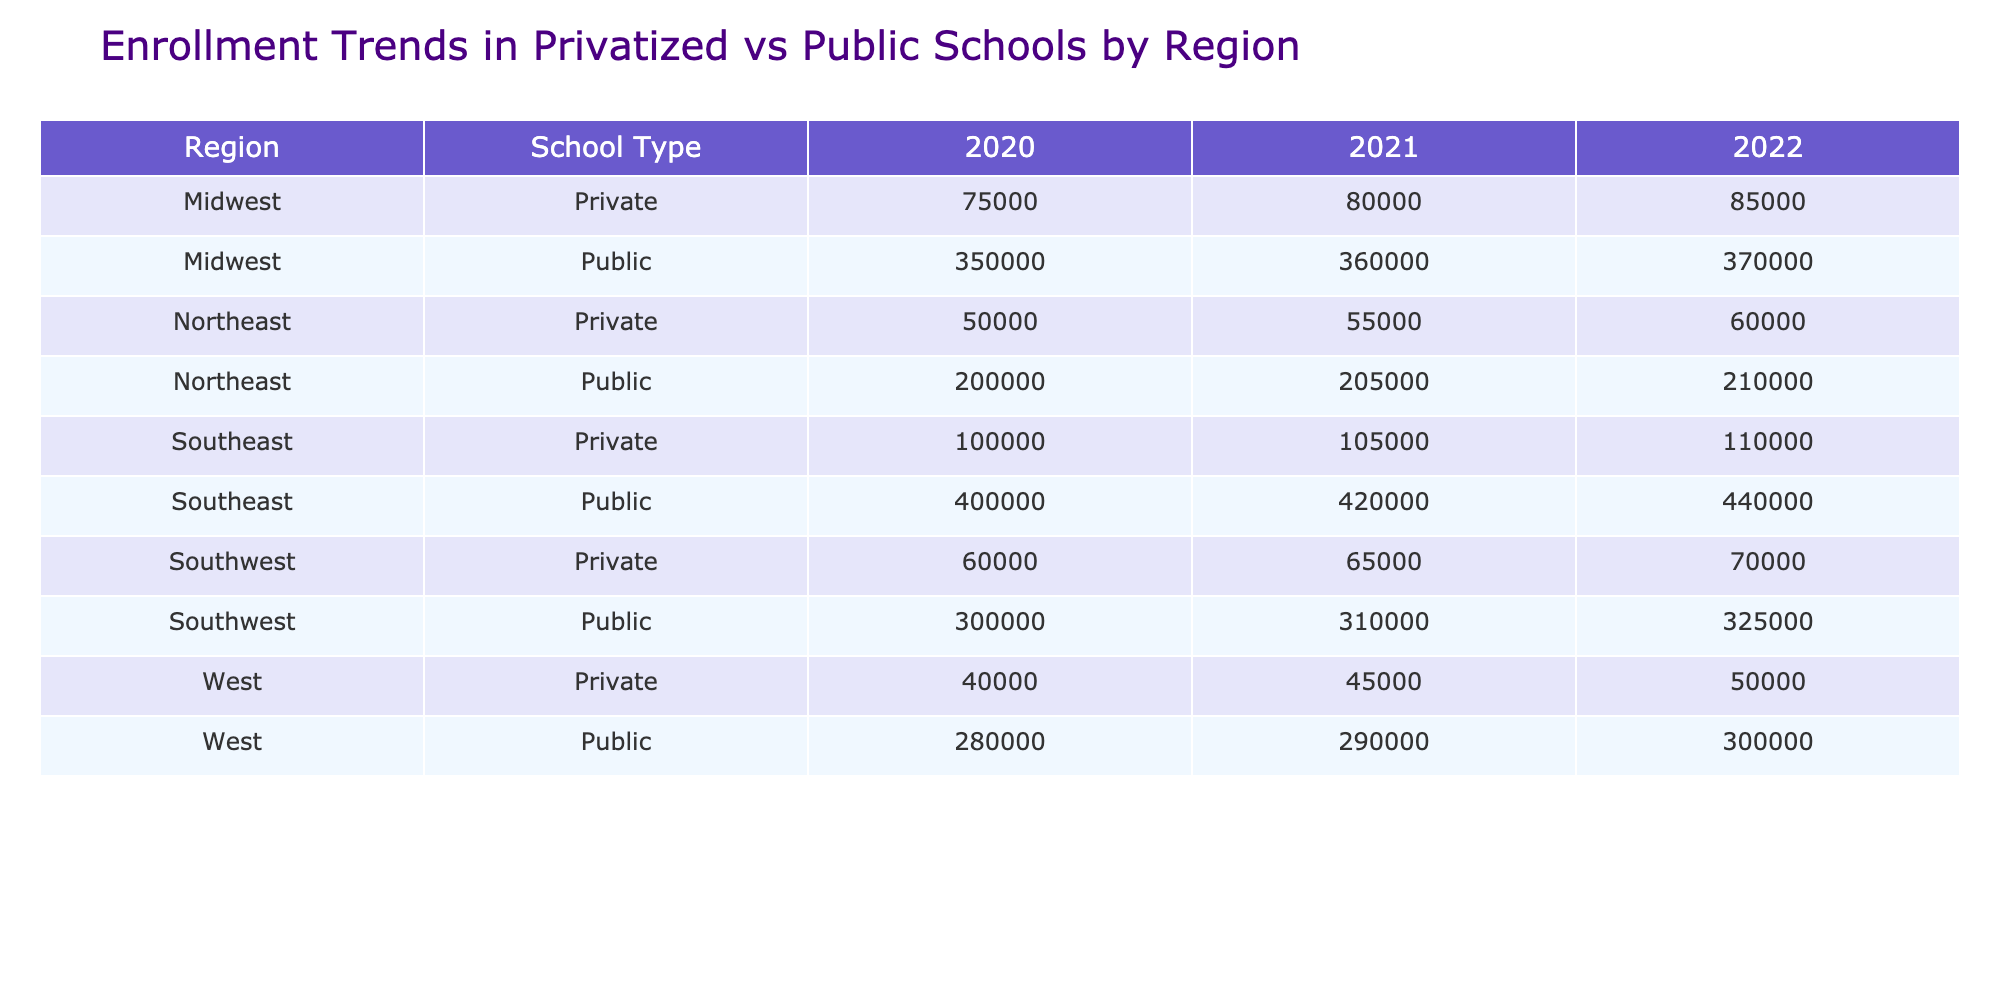What was the total enrollment in public schools in the Northeast for the year 2021? The total enrollment in public schools in the Northeast for 2021 is listed in the table under the Northeast and Public rows for that year, which shows 205000.
Answer: 205000 What was the enrollment in private schools in the Southeast in 2022? The enrollment in private schools in the Southeast for 2022 can be found in the table, specifically in the Southeast and Private rows, which indicates 110000.
Answer: 110000 Which region had the highest total enrollment in private schools in 2020? To determine which region had the highest total enrollment in private schools for 2020, look at the private school enrollments for all regions in that year: Northeast (50000), Southeast (100000), Midwest (75000), Southwest (60000), and West (40000). The Southeast has the highest enrollment, totaling 100000.
Answer: Southeast What is the average enrollment for public schools across all regions in 2022? The enrollment for public schools in 2022 across all regions is: Northeast (210000), Southeast (440000), Midwest (370000), Southwest (325000), and West (300000). Adding these figures gives a total of 210000 + 440000 + 370000 + 325000 + 300000 = 1675000. Since there are 5 regions, the average enrollment is 1675000 / 5 = 335000.
Answer: 335000 Is the enrollment in private schools in the Midwest higher than in the West for 2022? In 2022, the enrollment in private schools is noted in the table as 85000 in the Midwest and 50000 in the West. Since 85000 is higher than 50000, the statement is true.
Answer: Yes Which type of school saw a decrease in enrollment from 2021 to 2022 in the Southwest region? The enrollment for public schools in the Southwest for 2021 is 310000, and for 2022 it is 325000, which shows an increase. The private schools' enrollment for 2021 is 65000, and for 2022 is 70000, showing an increase as well. Thus, neither school type saw a decrease.
Answer: None What was the percentage increase in enrollment for private schools in the Northeast from 2020 to 2021? The enrollment for private schools in the Northeast for 2020 is 50000 and for 2021 is 55000. The increase is 55000 - 50000 = 5000. To find the percentage increase, calculate (5000 / 50000) * 100 = 10%.
Answer: 10% Which region experienced the largest growth in public school enrollment from 2020 to 2022? The public school enrollments are: Northeast (200000 to 210000: increase of 10000), Southeast (400000 to 440000: increase of 40000), Midwest (350000 to 370000: increase of 20000), Southwest (300000 to 325000: increase of 25000), and West (280000 to 300000: increase of 20000). The largest growth is in the Southeast with an increase of 40000.
Answer: Southeast 